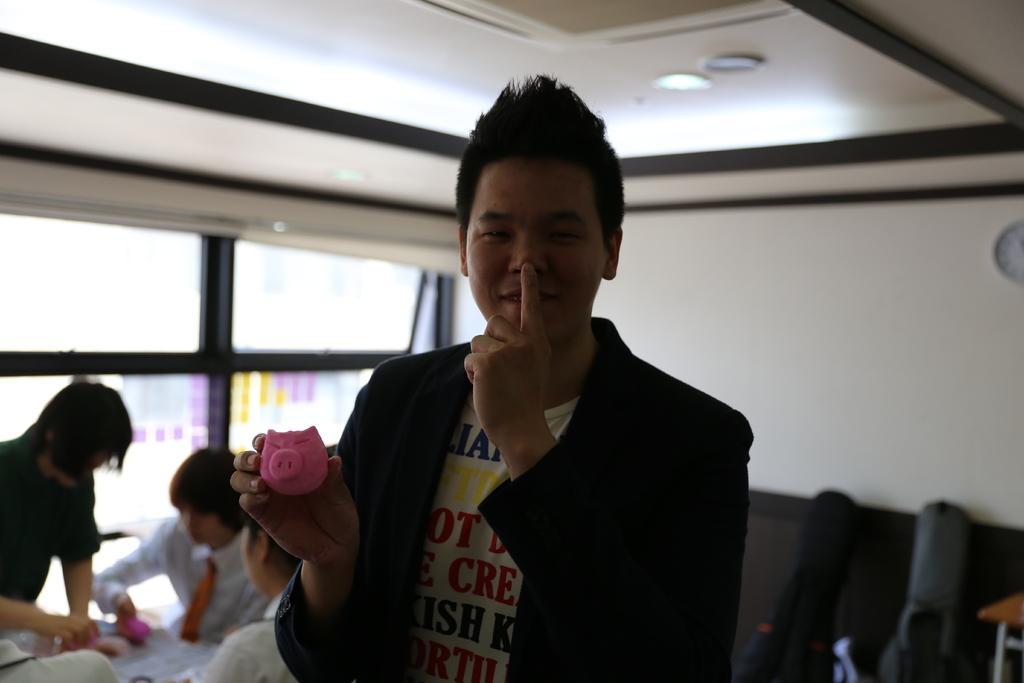Can you describe this image briefly? In this image there is a man in the middle who kept his finger on his mouth and with the other hand he is holding the toy. At the top there is ceiling with the lights. On the left side there are few people who are doing the work. On the right side there are two guitar bags on the floor. 